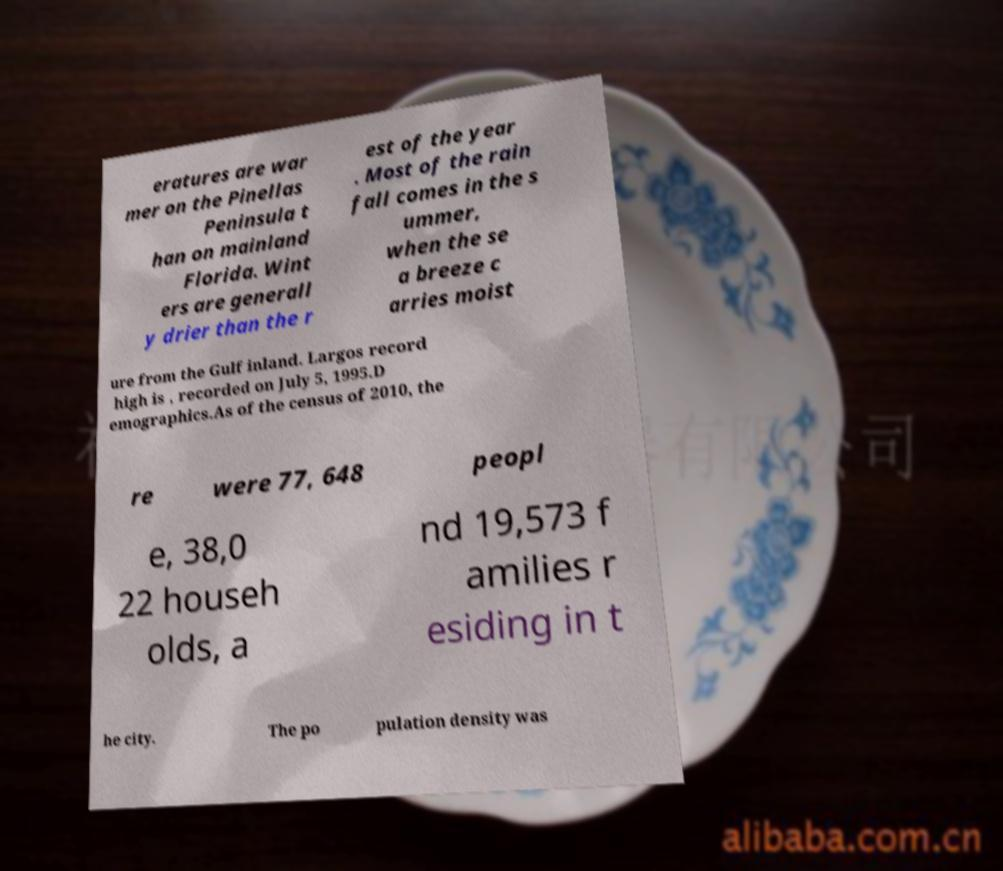Could you extract and type out the text from this image? eratures are war mer on the Pinellas Peninsula t han on mainland Florida. Wint ers are generall y drier than the r est of the year . Most of the rain fall comes in the s ummer, when the se a breeze c arries moist ure from the Gulf inland. Largos record high is , recorded on July 5, 1995.D emographics.As of the census of 2010, the re were 77, 648 peopl e, 38,0 22 househ olds, a nd 19,573 f amilies r esiding in t he city. The po pulation density was 